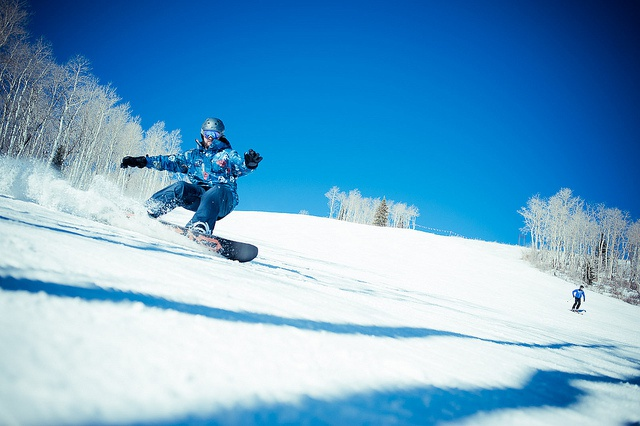Describe the objects in this image and their specific colors. I can see people in navy, blue, black, and teal tones, snowboard in navy, gray, blue, and lightgray tones, people in navy, white, black, blue, and gray tones, snowboard in navy, lightgray, blue, and darkgray tones, and skis in darkgray, lightgray, and navy tones in this image. 